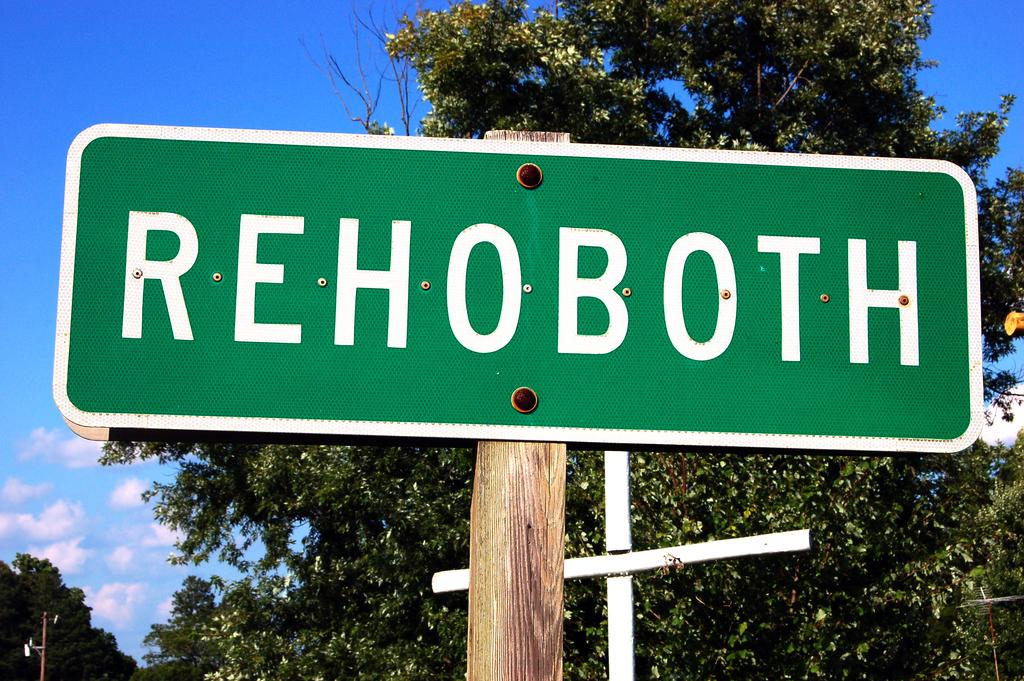What is the main object in the image? There is a sign board in the image. What can be seen in the background of the image? There are trees visible in the background of the image. What color is the sky in the image? The sky is blue in color and visible at the top of the image. What answer does the uncle provide in the image? There is no uncle or any dialogue present in the image, so it is not possible to determine an answer. 